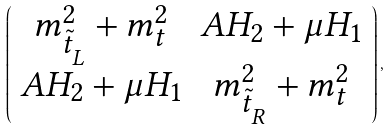Convert formula to latex. <formula><loc_0><loc_0><loc_500><loc_500>\left ( \begin{array} { c c } m ^ { 2 } _ { \tilde { t } _ { _ { L } } } + m _ { t } ^ { 2 } & A H _ { 2 } + \mu H _ { 1 } \\ A H _ { 2 } + \mu H _ { 1 } & m ^ { 2 } _ { \tilde { t } _ { _ { R } } } + m _ { t } ^ { 2 } \end{array} \right ) ,</formula> 